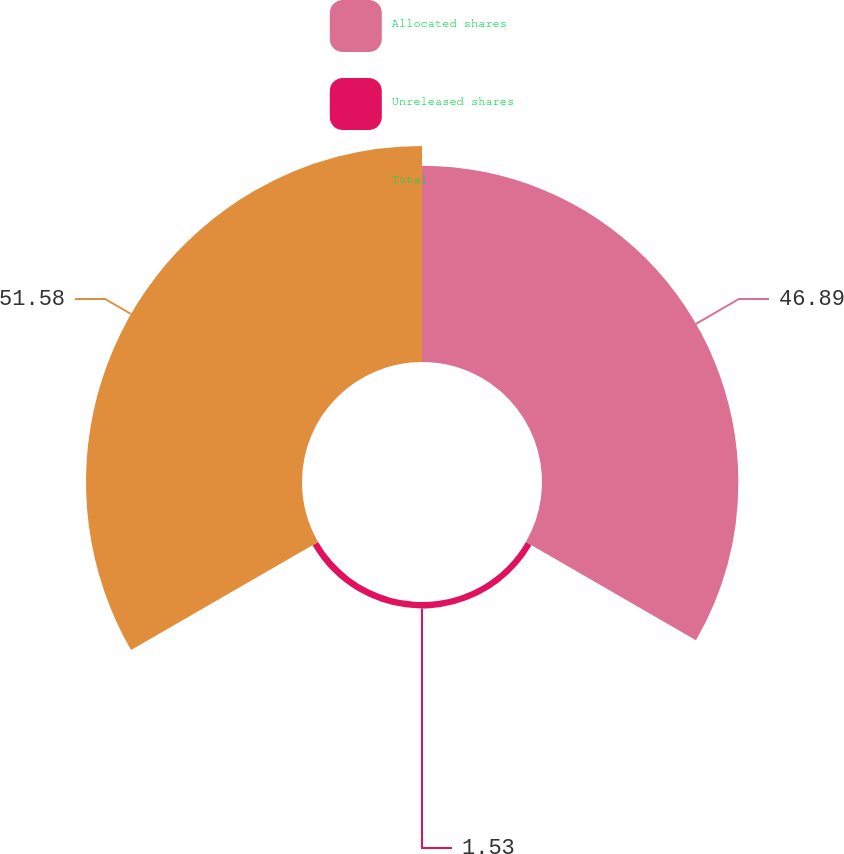<chart> <loc_0><loc_0><loc_500><loc_500><pie_chart><fcel>Allocated shares<fcel>Unreleased shares<fcel>Total<nl><fcel>46.89%<fcel>1.53%<fcel>51.58%<nl></chart> 